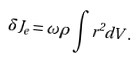<formula> <loc_0><loc_0><loc_500><loc_500>\delta J _ { e } = \omega \rho \int r ^ { 2 } d V \, .</formula> 